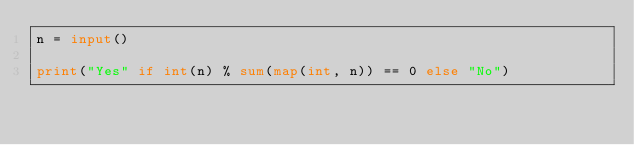<code> <loc_0><loc_0><loc_500><loc_500><_Python_>n = input()

print("Yes" if int(n) % sum(map(int, n)) == 0 else "No")</code> 